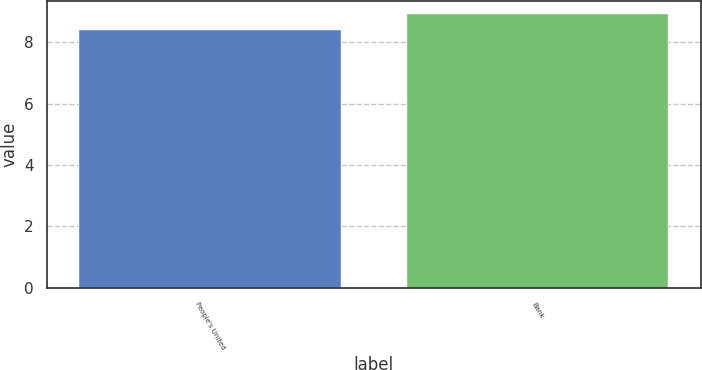Convert chart. <chart><loc_0><loc_0><loc_500><loc_500><bar_chart><fcel>People's United<fcel>Bank<nl><fcel>8.4<fcel>8.9<nl></chart> 